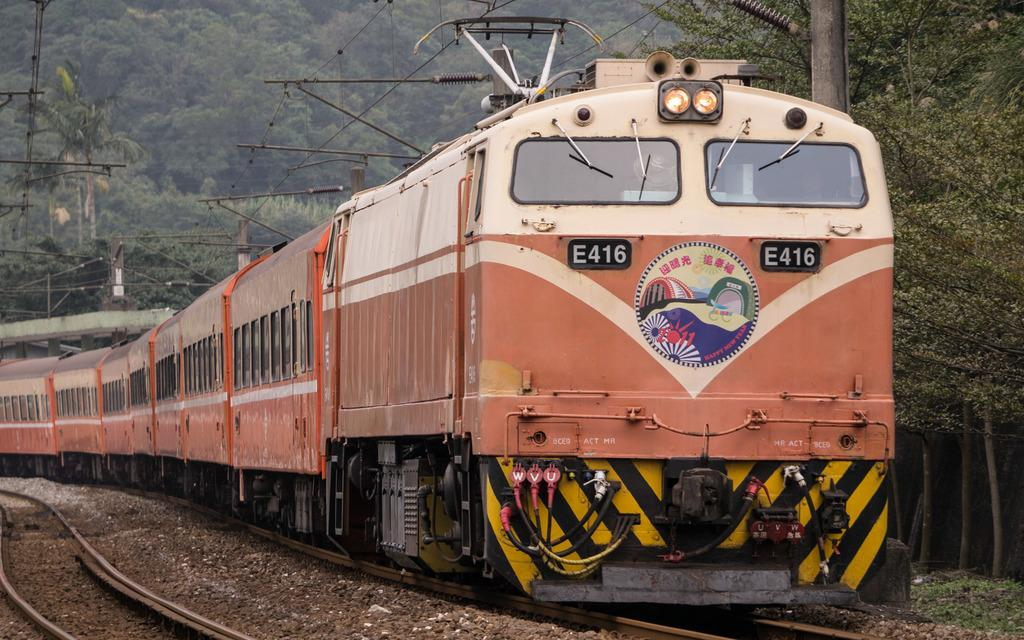<image>
Offer a succinct explanation of the picture presented. An older looking train with the name E416. 